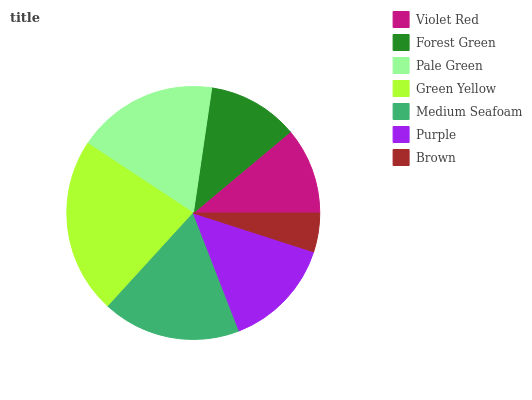Is Brown the minimum?
Answer yes or no. Yes. Is Green Yellow the maximum?
Answer yes or no. Yes. Is Forest Green the minimum?
Answer yes or no. No. Is Forest Green the maximum?
Answer yes or no. No. Is Forest Green greater than Violet Red?
Answer yes or no. Yes. Is Violet Red less than Forest Green?
Answer yes or no. Yes. Is Violet Red greater than Forest Green?
Answer yes or no. No. Is Forest Green less than Violet Red?
Answer yes or no. No. Is Purple the high median?
Answer yes or no. Yes. Is Purple the low median?
Answer yes or no. Yes. Is Brown the high median?
Answer yes or no. No. Is Forest Green the low median?
Answer yes or no. No. 